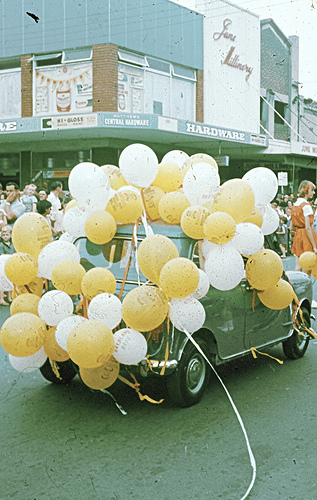<image>
Is the balloon next to the car? Yes. The balloon is positioned adjacent to the car, located nearby in the same general area. Where is the ballons in relation to the car? Is it on the car? Yes. Looking at the image, I can see the ballons is positioned on top of the car, with the car providing support. Is there a balloon to the right of the car? No. The balloon is not to the right of the car. The horizontal positioning shows a different relationship. 